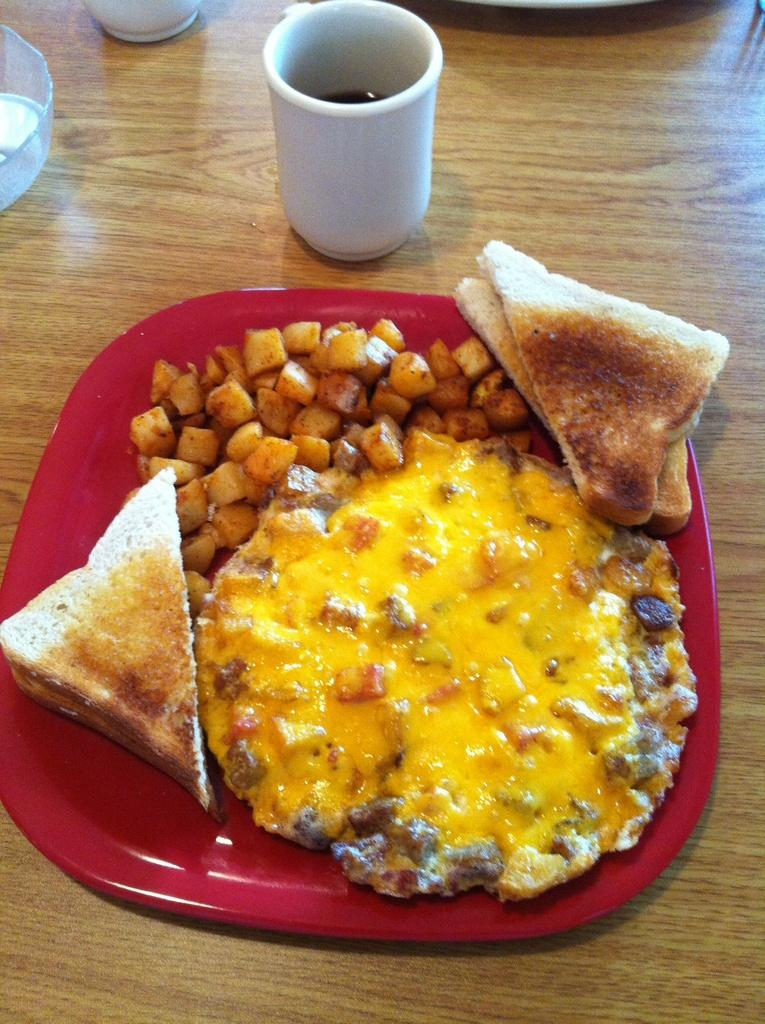What type of table is in the image? There is a wooden table in the image. What is on the table? There is a white cup and a red plate on the table. What is on the red plate? There are toasted breads, fried potato pieces, and a yellow color food item on the plate. How does the story of the ant relate to the image? There is no mention of an ant or a story in the image, so it is not possible to relate them. 